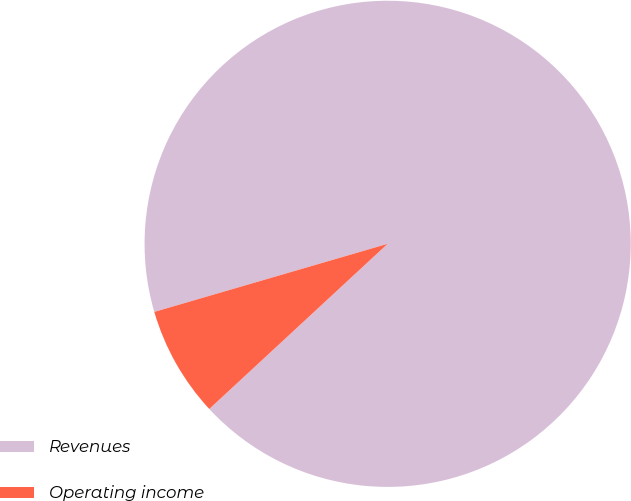<chart> <loc_0><loc_0><loc_500><loc_500><pie_chart><fcel>Revenues<fcel>Operating income<nl><fcel>92.63%<fcel>7.37%<nl></chart> 